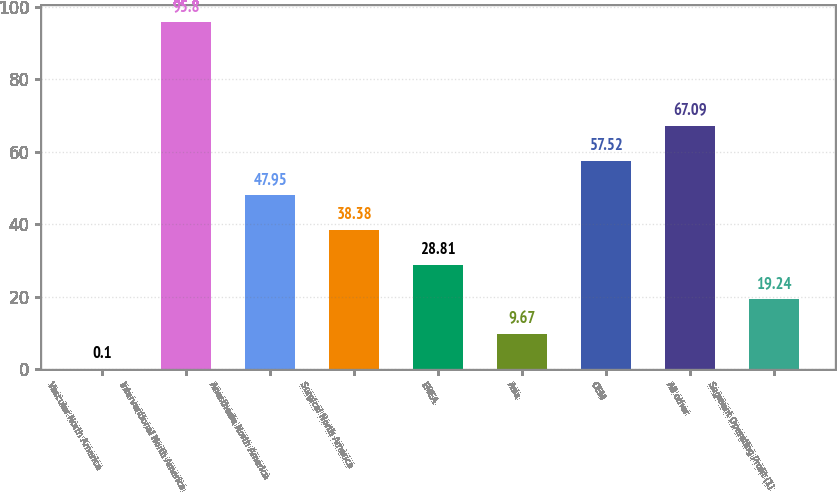<chart> <loc_0><loc_0><loc_500><loc_500><bar_chart><fcel>Vascular North America<fcel>Interventional North America<fcel>Anesthesia North America<fcel>Surgical North America<fcel>EMEA<fcel>Asia<fcel>OEM<fcel>All other<fcel>Segment Operating Profit (1)<nl><fcel>0.1<fcel>95.8<fcel>47.95<fcel>38.38<fcel>28.81<fcel>9.67<fcel>57.52<fcel>67.09<fcel>19.24<nl></chart> 